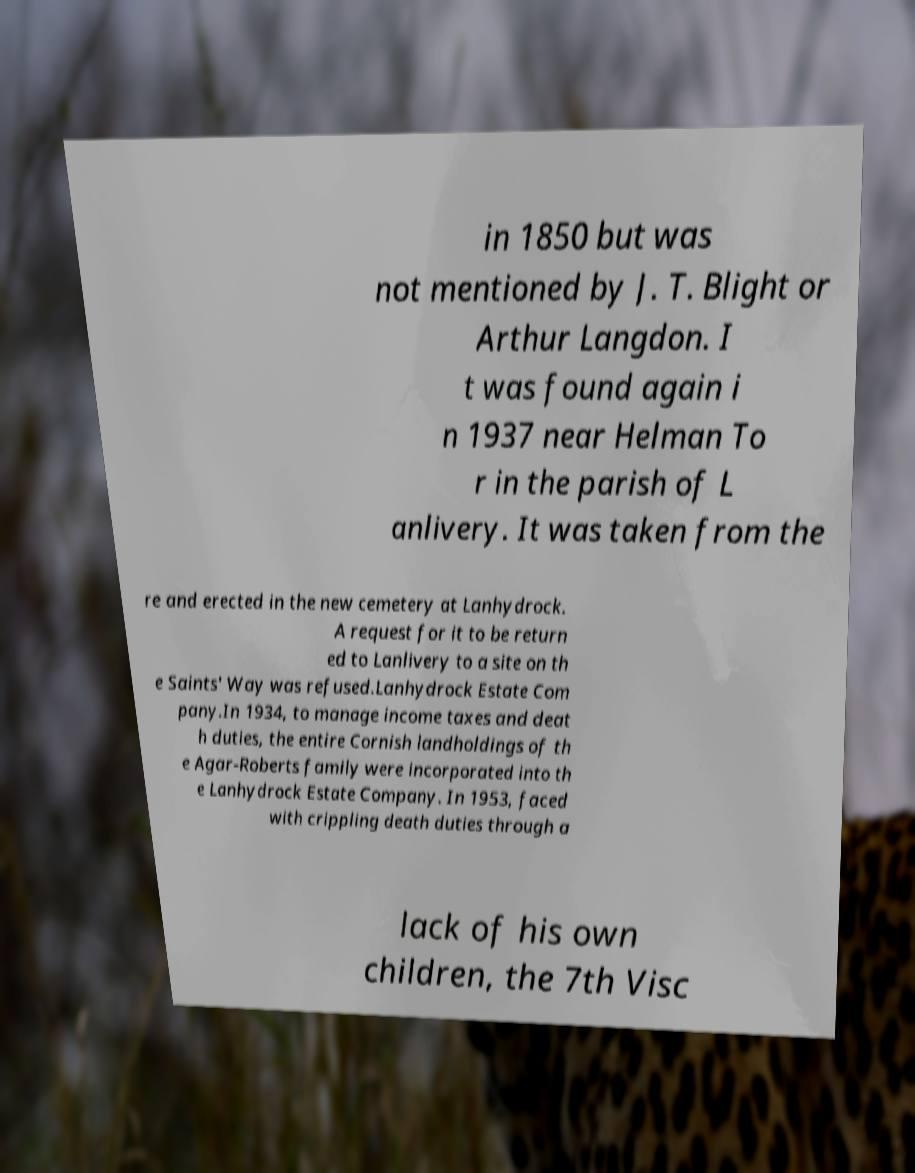Could you assist in decoding the text presented in this image and type it out clearly? in 1850 but was not mentioned by J. T. Blight or Arthur Langdon. I t was found again i n 1937 near Helman To r in the parish of L anlivery. It was taken from the re and erected in the new cemetery at Lanhydrock. A request for it to be return ed to Lanlivery to a site on th e Saints' Way was refused.Lanhydrock Estate Com pany.In 1934, to manage income taxes and deat h duties, the entire Cornish landholdings of th e Agar-Roberts family were incorporated into th e Lanhydrock Estate Company. In 1953, faced with crippling death duties through a lack of his own children, the 7th Visc 